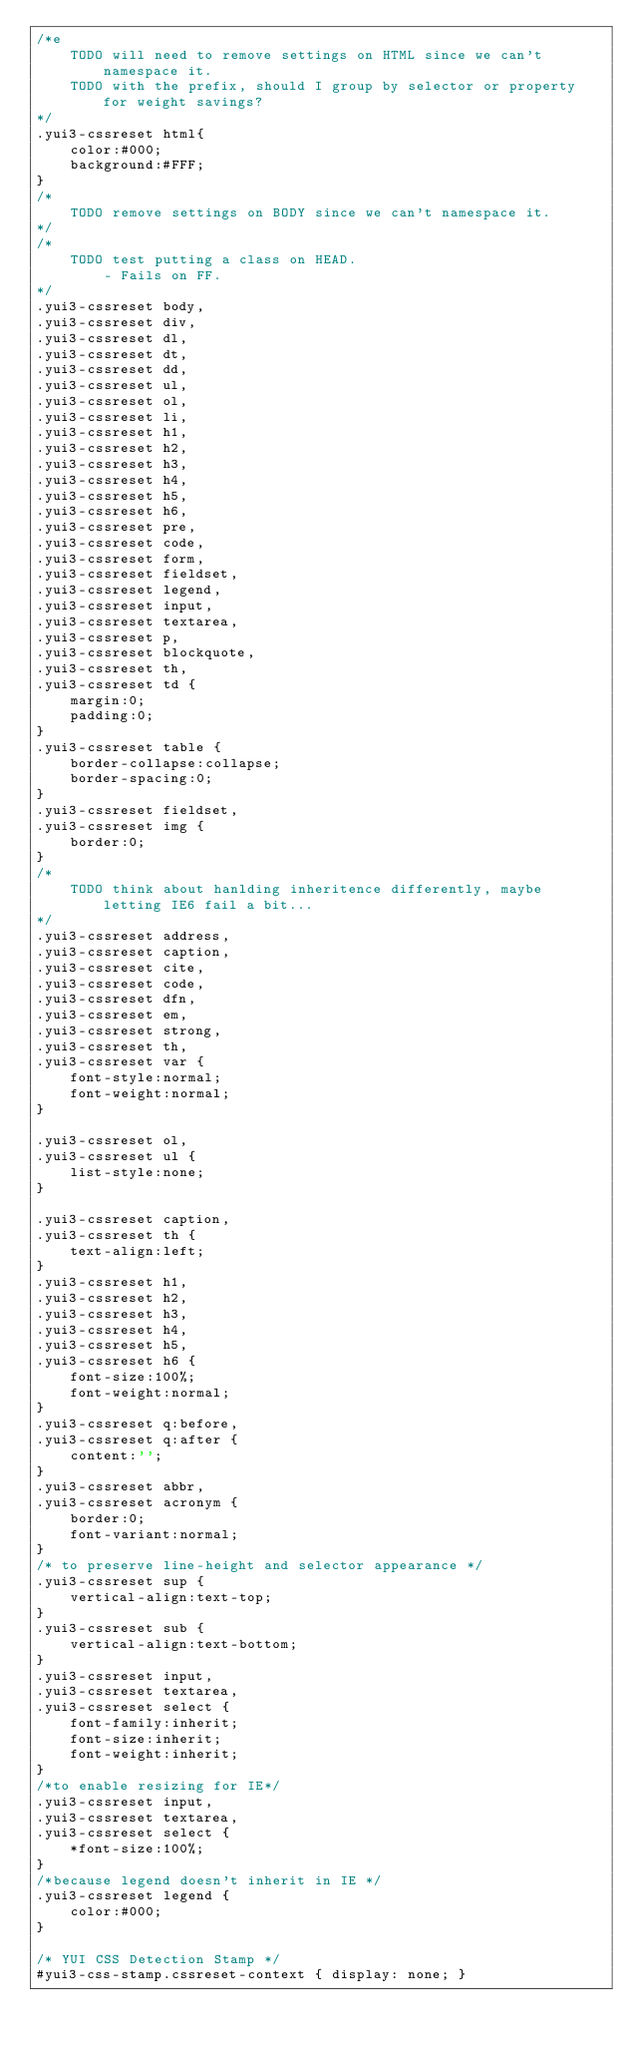Convert code to text. <code><loc_0><loc_0><loc_500><loc_500><_CSS_>/*e
	TODO will need to remove settings on HTML since we can't namespace it.
	TODO with the prefix, should I group by selector or property for weight savings?
*/
.yui3-cssreset html{
	color:#000;
	background:#FFF;
}
/*
	TODO remove settings on BODY since we can't namespace it.
*/
/*
	TODO test putting a class on HEAD.
		- Fails on FF. 
*/
.yui3-cssreset body,
.yui3-cssreset div,
.yui3-cssreset dl,
.yui3-cssreset dt,
.yui3-cssreset dd,
.yui3-cssreset ul,
.yui3-cssreset ol,
.yui3-cssreset li,
.yui3-cssreset h1,
.yui3-cssreset h2,
.yui3-cssreset h3,
.yui3-cssreset h4,
.yui3-cssreset h5,
.yui3-cssreset h6,
.yui3-cssreset pre,
.yui3-cssreset code,
.yui3-cssreset form,
.yui3-cssreset fieldset,
.yui3-cssreset legend,
.yui3-cssreset input,
.yui3-cssreset textarea,
.yui3-cssreset p,
.yui3-cssreset blockquote,
.yui3-cssreset th,
.yui3-cssreset td {
	margin:0;
	padding:0;
}
.yui3-cssreset table {
	border-collapse:collapse;
	border-spacing:0;
}
.yui3-cssreset fieldset,
.yui3-cssreset img {
	border:0;
}
/*
	TODO think about hanlding inheritence differently, maybe letting IE6 fail a bit...
*/
.yui3-cssreset address,
.yui3-cssreset caption,
.yui3-cssreset cite,
.yui3-cssreset code,
.yui3-cssreset dfn,
.yui3-cssreset em,
.yui3-cssreset strong,
.yui3-cssreset th,
.yui3-cssreset var {
	font-style:normal;
	font-weight:normal;
}

.yui3-cssreset ol,
.yui3-cssreset ul {
	list-style:none;
}

.yui3-cssreset caption,
.yui3-cssreset th {
	text-align:left;
}
.yui3-cssreset h1,
.yui3-cssreset h2,
.yui3-cssreset h3,
.yui3-cssreset h4,
.yui3-cssreset h5,
.yui3-cssreset h6 {
	font-size:100%;
	font-weight:normal;
}
.yui3-cssreset q:before,
.yui3-cssreset q:after {
	content:'';
}
.yui3-cssreset abbr,
.yui3-cssreset acronym {
	border:0;
	font-variant:normal;
}
/* to preserve line-height and selector appearance */
.yui3-cssreset sup {
	vertical-align:text-top;
}
.yui3-cssreset sub {
	vertical-align:text-bottom;
}
.yui3-cssreset input,
.yui3-cssreset textarea,
.yui3-cssreset select {
	font-family:inherit;
	font-size:inherit;
	font-weight:inherit;
}
/*to enable resizing for IE*/
.yui3-cssreset input,
.yui3-cssreset textarea,
.yui3-cssreset select {
	*font-size:100%;
}
/*because legend doesn't inherit in IE */
.yui3-cssreset legend {
	color:#000;
}

/* YUI CSS Detection Stamp */
#yui3-css-stamp.cssreset-context { display: none; }
</code> 